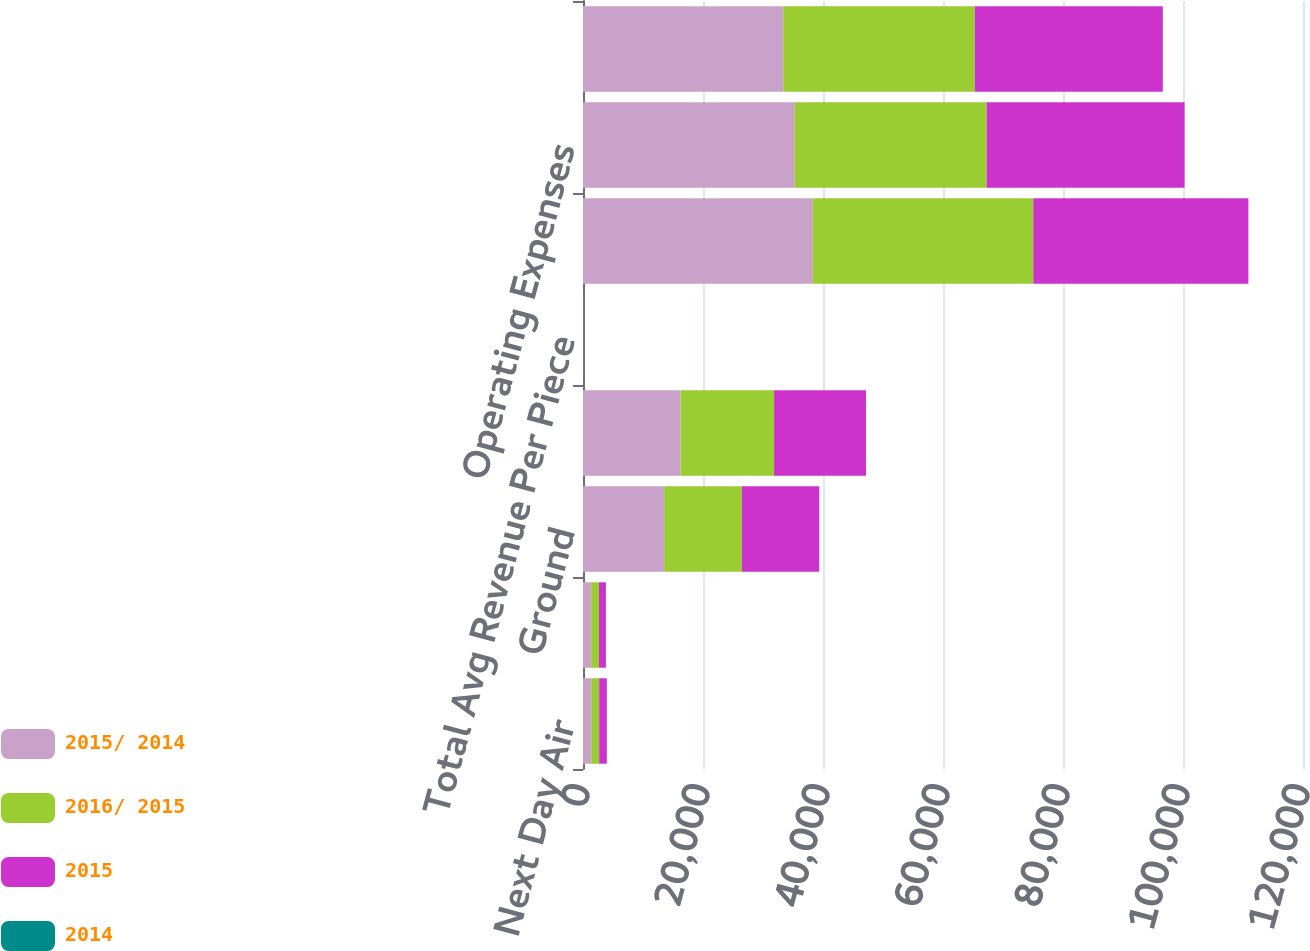Convert chart to OTSL. <chart><loc_0><loc_0><loc_500><loc_500><stacked_bar_chart><ecel><fcel>Next Day Air<fcel>Deferred<fcel>Ground<fcel>Total Avg Daily Package Volume<fcel>Total Avg Revenue Per Piece<fcel>Total Revenue<fcel>Operating Expenses<fcel>Adjusted Operating Expenses<nl><fcel>2015/ 2014<fcel>1379<fcel>1351<fcel>13515<fcel>16245<fcel>9.25<fcel>38301<fcel>35284<fcel>33376<nl><fcel>2016/ 2015<fcel>1316<fcel>1313<fcel>12969<fcel>15598<fcel>9.28<fcel>36747<fcel>31980<fcel>31918<nl><fcel>2015<fcel>1274<fcel>1155<fcel>12893<fcel>15322<fcel>9.25<fcel>35851<fcel>32992<fcel>31342<nl><fcel>2014<fcel>4.8<fcel>2.9<fcel>4.2<fcel>4.1<fcel>0.3<fcel>4.2<fcel>10.3<fcel>4.6<nl></chart> 